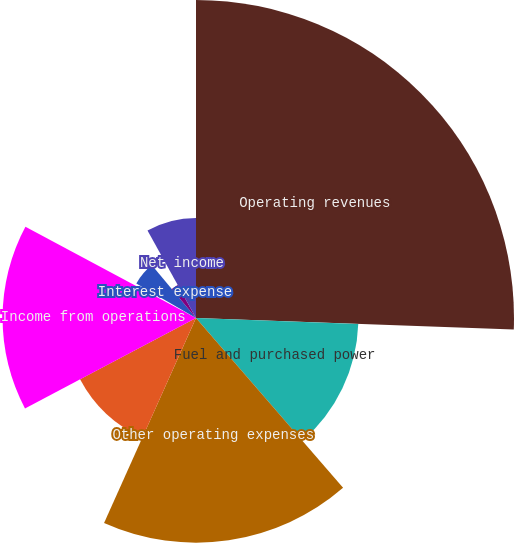Convert chart to OTSL. <chart><loc_0><loc_0><loc_500><loc_500><pie_chart><fcel>Operating revenues<fcel>Fuel and purchased power<fcel>Other operating expenses<fcel>Depreciation and amortization<fcel>Income from operations<fcel>Other income (expense) net<fcel>Interest expense<fcel>Income tax expense<fcel>Net income<nl><fcel>25.58%<fcel>13.06%<fcel>18.07%<fcel>10.55%<fcel>15.56%<fcel>0.54%<fcel>5.55%<fcel>3.04%<fcel>8.05%<nl></chart> 